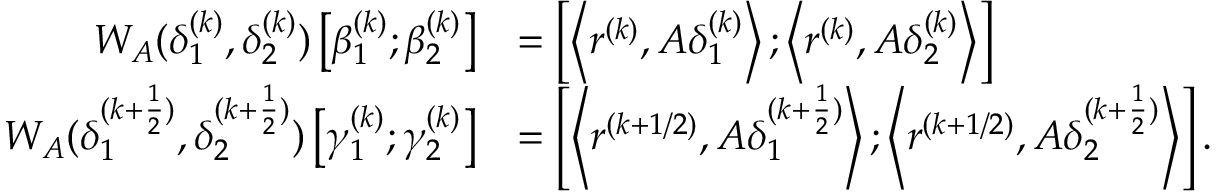Convert formula to latex. <formula><loc_0><loc_0><loc_500><loc_500>\begin{array} { r l } { W _ { A } ( \delta _ { 1 } ^ { ( k ) } , \delta _ { 2 } ^ { ( k ) } ) \left [ { \beta _ { 1 } ^ { ( k ) } ; \beta _ { 2 } ^ { ( k ) } } \right ] } & { = \left [ { \left \langle { { r ^ { ( k ) } } , A \delta _ { 1 } ^ { ( k ) } } \right \rangle ; \left \langle { { r ^ { ( k ) } } , A \delta _ { 2 } ^ { ( k ) } } \right \rangle } \right ] } \\ { W _ { A } ( \delta _ { 1 } ^ { ( k + \frac { 1 } { 2 } ) } , \delta _ { 2 } ^ { ( k + \frac { 1 } { 2 } ) } ) \left [ { \gamma _ { 1 } ^ { ( k ) } ; \gamma _ { 2 } ^ { ( k ) } } \right ] } & { = \left [ { \left \langle { { r ^ { ( k + 1 / 2 ) } } , A \delta _ { 1 } ^ { ( k + \frac { 1 } { 2 } ) } } \right \rangle ; \left \langle { { r ^ { ( k + 1 / 2 ) } } , A \delta _ { 2 } ^ { ( k + \frac { 1 } { 2 } ) } } \right \rangle } \right ] . } \end{array}</formula> 